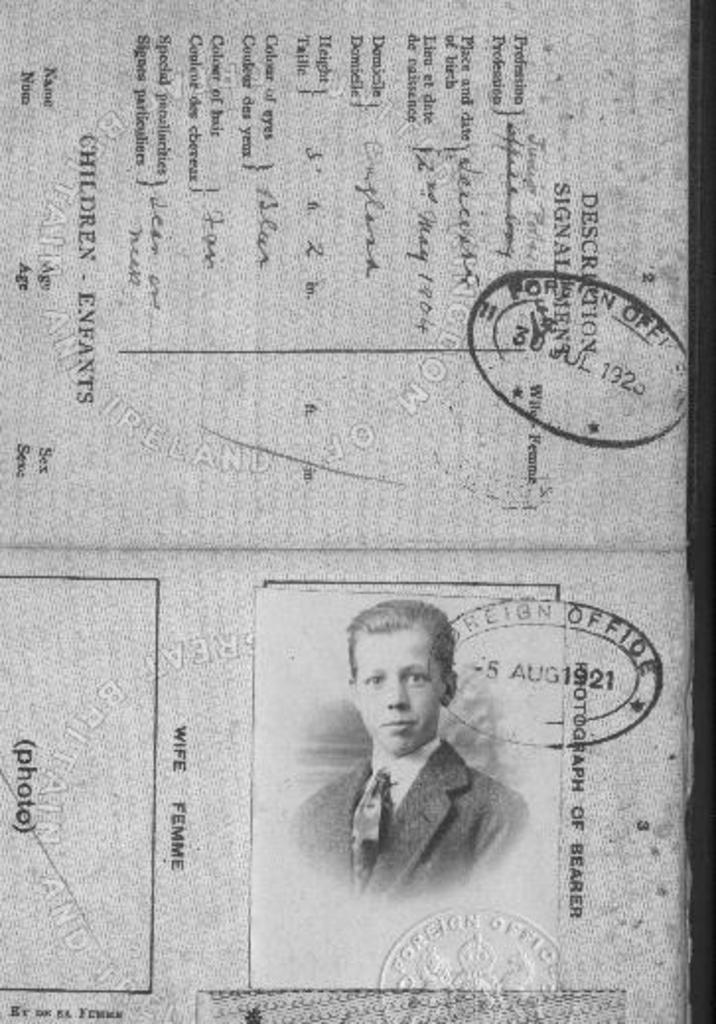What is the main object in the image? There is a paper in the image. What is written or printed on the paper? The paper contains text. Are there any additional elements on the paper? Yes, the paper has stamps on it. Can you describe the person depicted on the paper? There is a person on the paper. What is the color scheme of the image? The image is in black and white color. What type of fuel is being used by the coach in the image? There is no coach or fuel present in the image; it features a paper with text, stamps, and a person. Can you tell me how many pigs are visible in the image? There are no pigs present in the image. 